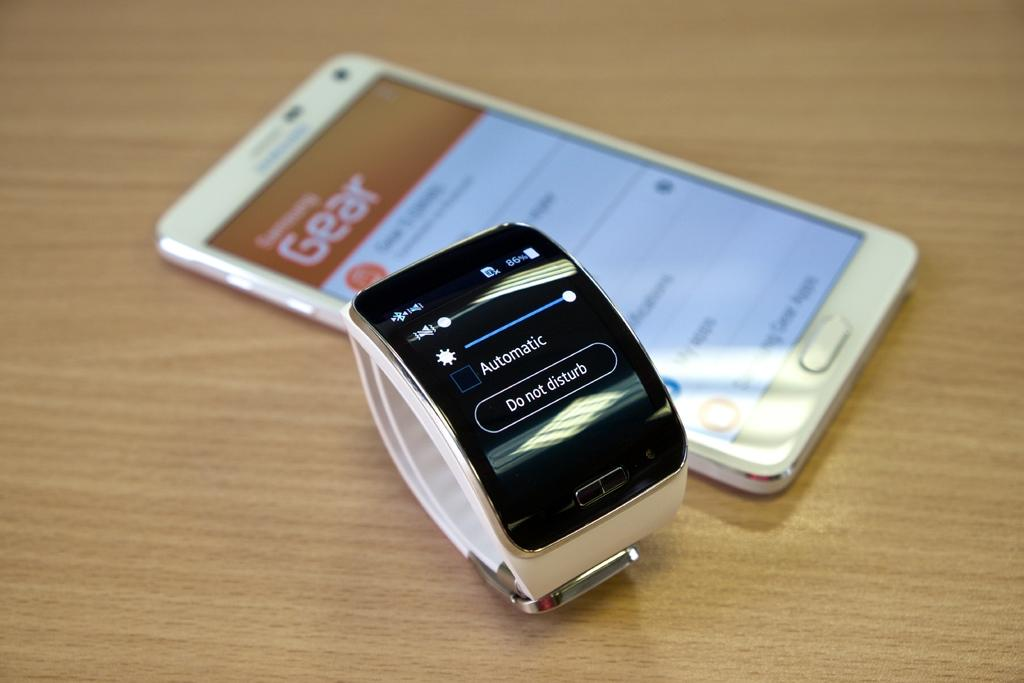What electronic device is visible in the image? There is a mobile phone in the image. What time-keeping device is also present in the image? There is a watch in the image. On what type of surface are the mobile phone and watch placed? The mobile phone and watch are on a wooden surface. Can you see any waves crashing on the shore in the image? There are no waves or shore visible in the image; it features a mobile phone and watch on a wooden surface. What theory is being discussed in the image? There is no discussion or theory present in the image; it only shows a mobile phone and watch on a wooden surface. 